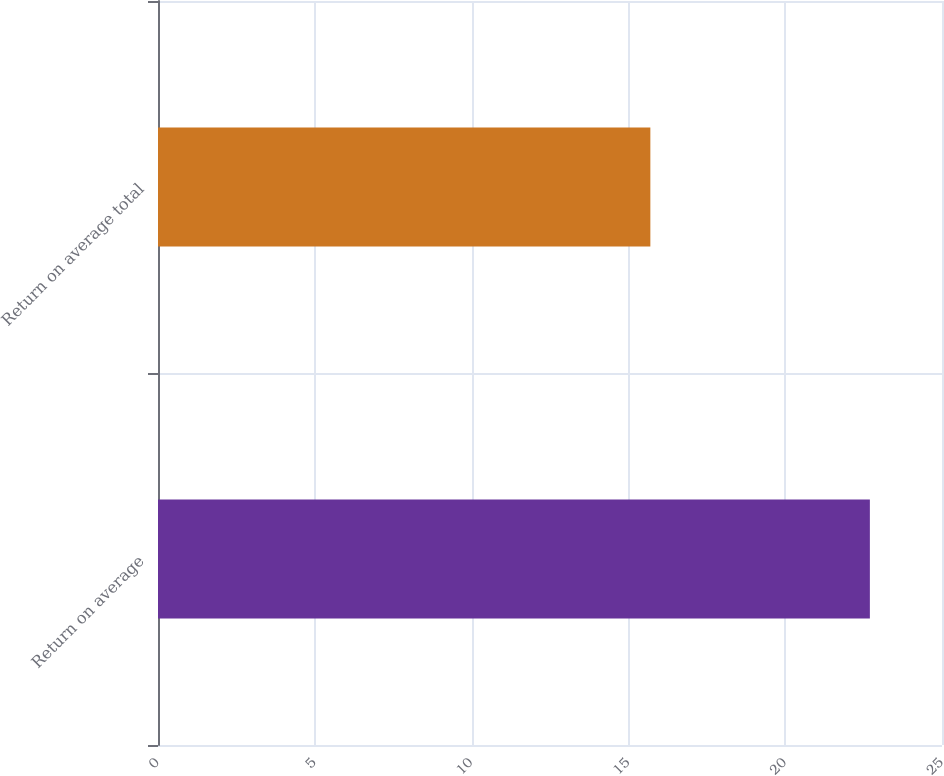Convert chart. <chart><loc_0><loc_0><loc_500><loc_500><bar_chart><fcel>Return on average<fcel>Return on average total<nl><fcel>22.7<fcel>15.7<nl></chart> 